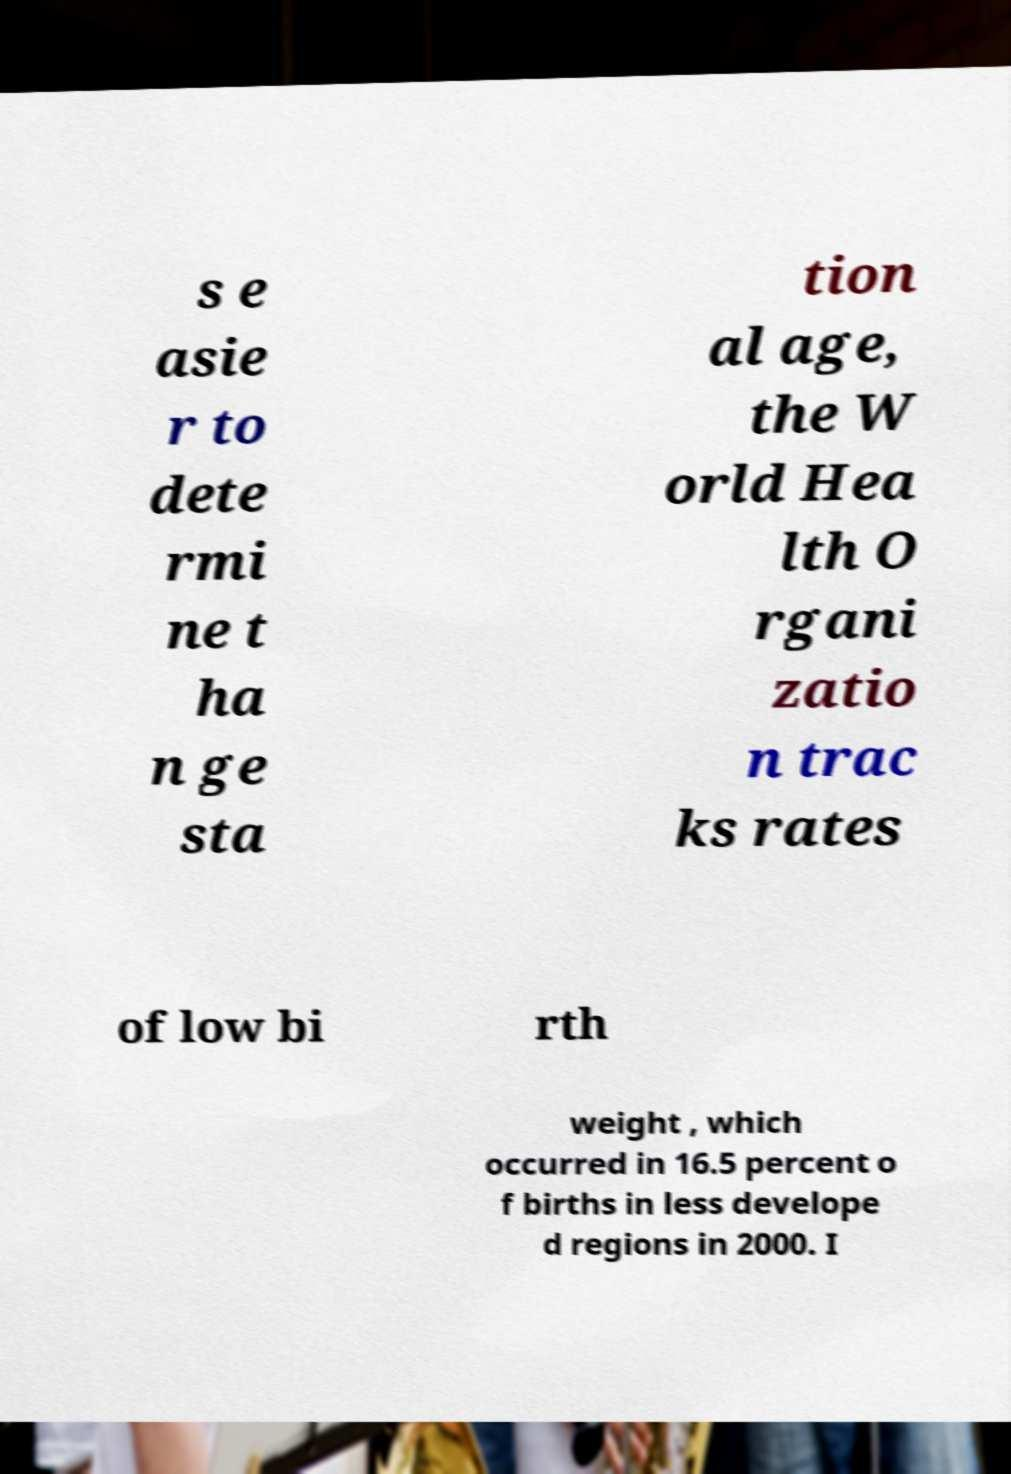I need the written content from this picture converted into text. Can you do that? s e asie r to dete rmi ne t ha n ge sta tion al age, the W orld Hea lth O rgani zatio n trac ks rates of low bi rth weight , which occurred in 16.5 percent o f births in less develope d regions in 2000. I 